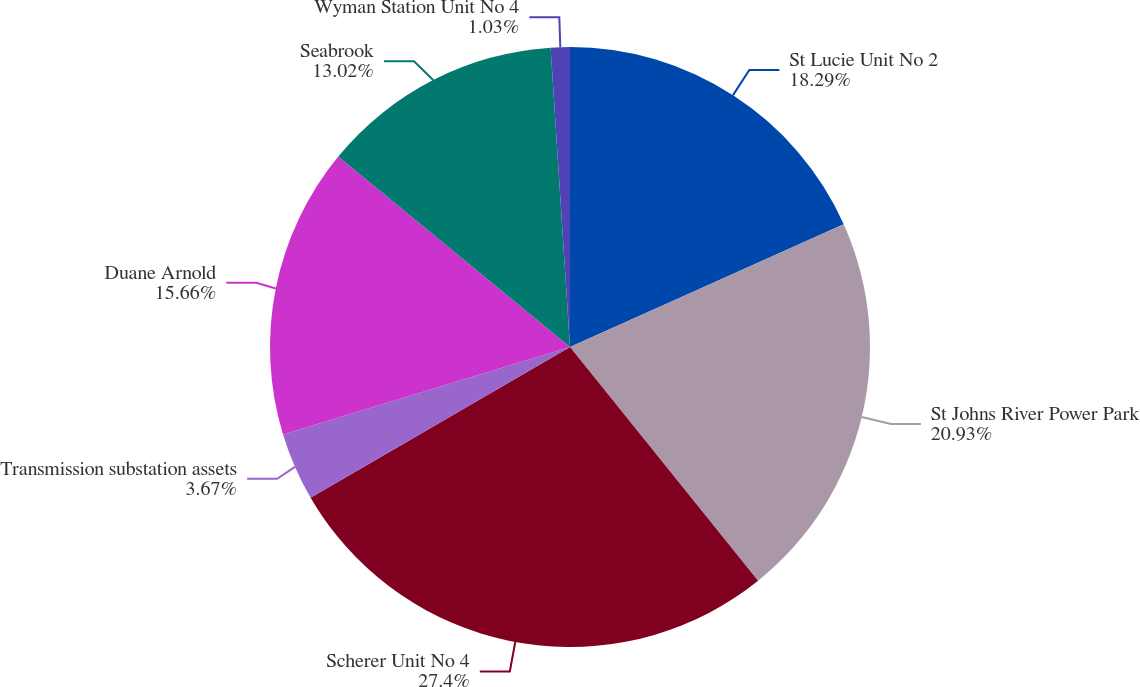Convert chart. <chart><loc_0><loc_0><loc_500><loc_500><pie_chart><fcel>St Lucie Unit No 2<fcel>St Johns River Power Park<fcel>Scherer Unit No 4<fcel>Transmission substation assets<fcel>Duane Arnold<fcel>Seabrook<fcel>Wyman Station Unit No 4<nl><fcel>18.29%<fcel>20.93%<fcel>27.41%<fcel>3.67%<fcel>15.66%<fcel>13.02%<fcel>1.03%<nl></chart> 